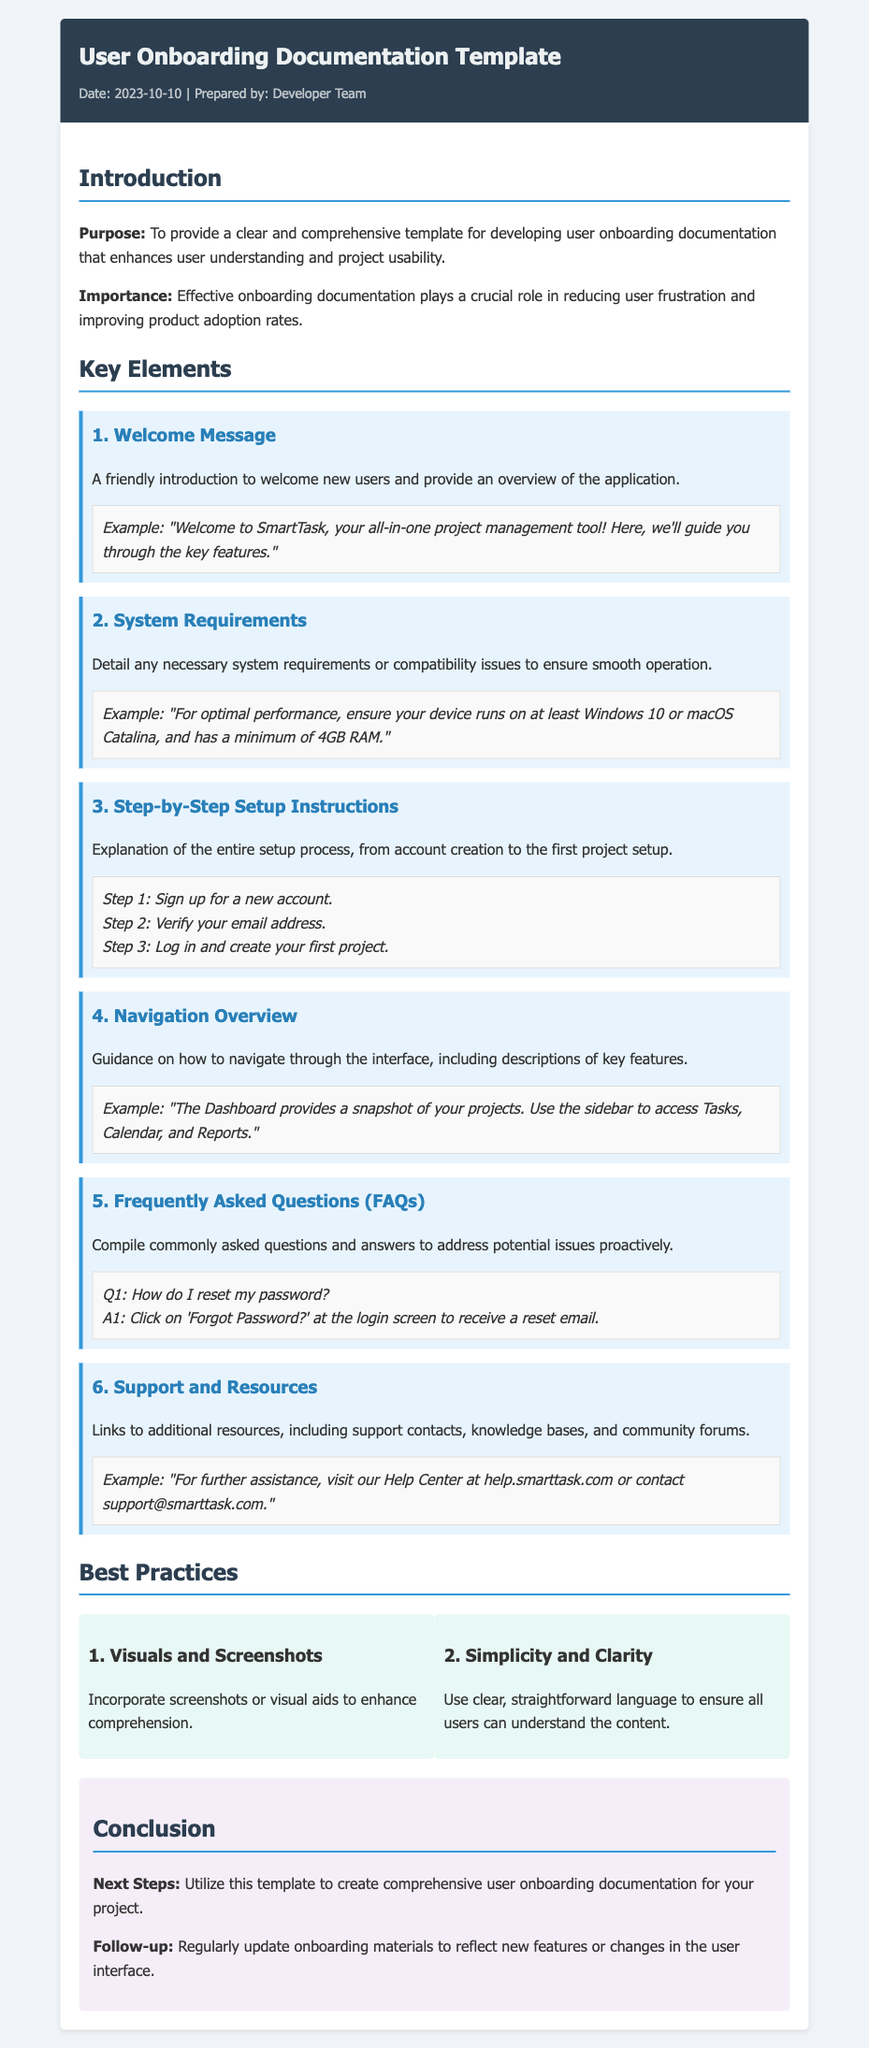what is the title of the document? The title is provided in the document header section, which identifies the key subject of the document.
Answer: User Onboarding Documentation Template who prepared the document? The prepared by section indicates the team responsible for the document.
Answer: Developer Team what is the purpose of the document? The purpose is clearly stated in the introduction section, explaining the document's intent.
Answer: To provide a clear and comprehensive template for developing user onboarding documentation how many key elements are listed in the document? The key elements are enumerated within their respective section, indicating how many there are.
Answer: 6 what is the first key element mentioned? The first key element is explicitly titled and described within the key elements section.
Answer: Welcome Message what best practice relates to visuals? Best practices are outlined with specific recommendations, focusing on different aspects of documentation.
Answer: Visuals and Screenshots what is mentioned in the conclusion for follow-up? The conclusion includes a specific follow-up action that is essential for maintaining documentation relevance.
Answer: Regularly update onboarding materials which section contains Frequently Asked Questions? The specific section headers make it clear where certain information is contained.
Answer: Key Elements what example is provided for system requirements? An example included offers details on required specifications for smooth operation.
Answer: For optimal performance, ensure your device runs on at least Windows 10 or macOS Catalina, and has a minimum of 4GB RAM 